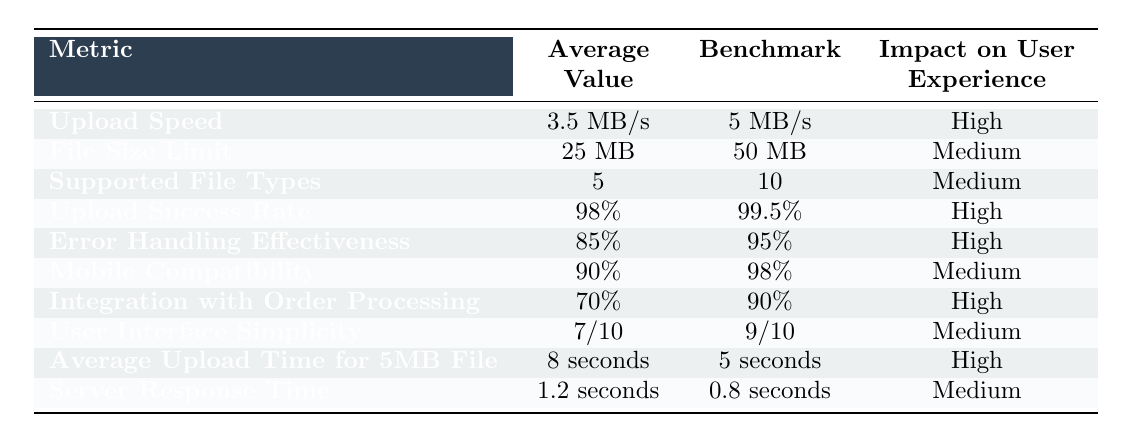What is the average upload speed for the file upload feature? The table shows that the average upload speed is 3.5 MB/s.
Answer: 3.5 MB/s What is the benchmark for upload success rate? The table indicates that the benchmark for upload success rate is 99.5%.
Answer: 99.5% Is the error handling effectiveness above 80%? The table shows error handling effectiveness as 85%, which is above 80%.
Answer: Yes What is the difference between the average upload time for a 5MB file and the benchmark? The average upload time is 8 seconds and the benchmark is 5 seconds. The difference is 8 - 5 = 3 seconds.
Answer: 3 seconds How many more supported file types does the benchmark allow compared to the average? The average supported file types is 5 and the benchmark is 10. The difference is 10 - 5 = 5 file types.
Answer: 5 file types Is mobile compatibility higher than 90%? The table states that mobile compatibility is 90%, which is not higher than 90%.
Answer: No What is the average upload speed compared to the benchmark? The average upload speed is 3.5 MB/s while the benchmark is 5 MB/s. The average is lower than the benchmark.
Answer: Lower If the upload success rate improved by 1%, would it still be below the benchmark? The current upload success rate is 98%. If it improves by 1%, it would be 99%. Since the benchmark is 99.5%, it would still be below the benchmark.
Answer: Yes What is the impact on user experience for the file size limit, and how does it compare to the upload success rate? The file size limit has a medium impact on user experience while the upload success rate has a high impact. Therefore, the upload success rate is more critical for user experience compared to the file size limit.
Answer: Higher How does the average server response time compare to the benchmark? The average server response time is 1.2 seconds compared to the benchmark of 0.8 seconds, making the average slower than the benchmark.
Answer: Slower If we consider both upload speed and average upload time, are they both below their respective benchmarks? The upload speed is 3.5 MB/s (below the benchmark of 5 MB/s) and the average upload time is 8 seconds (above the benchmark of 5 seconds). Therefore, only the upload speed is below the benchmark, while the upload time exceeds it.
Answer: No 